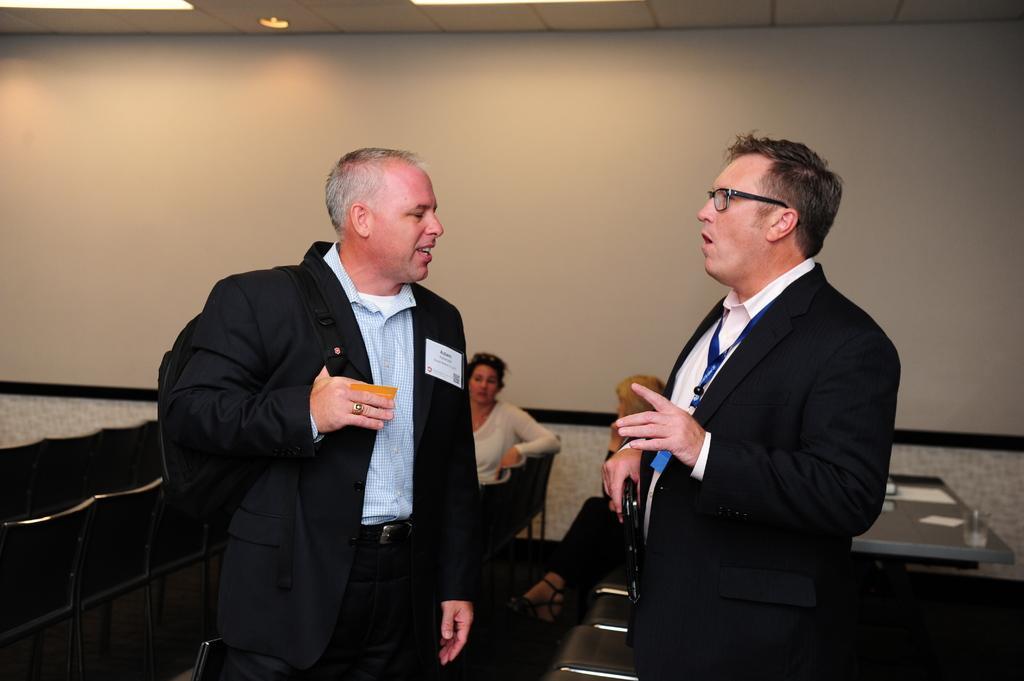In one or two sentences, can you explain what this image depicts? In this image, we can see a few people. We can also see a table with some objects on it. There are some chairs. We can also see the wall. We can see the roof with a light. 